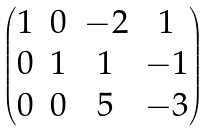<formula> <loc_0><loc_0><loc_500><loc_500>\begin{pmatrix} 1 & 0 & - 2 & 1 \\ 0 & 1 & 1 & - 1 \\ 0 & 0 & 5 & - 3 \\ \end{pmatrix}</formula> 